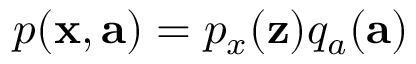<formula> <loc_0><loc_0><loc_500><loc_500>p ( x , a ) = p _ { x } ( z ) q _ { a } ( a )</formula> 